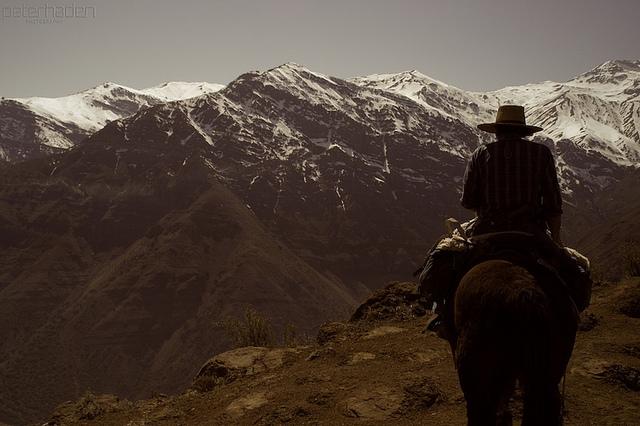What kind of animal is in the photo?
Be succinct. Horse. What is the focus of this picture?
Write a very short answer. Mountains. What animal is in the image?
Quick response, please. Horse. How many mountains are in the background?
Concise answer only. 5. Is the sky blue?
Answer briefly. No. Does this cowboy have a hat on?
Be succinct. Yes. What is the name of the mountain?
Answer briefly. Rocky. Is the cowboy wearing stripes?
Short answer required. No. 